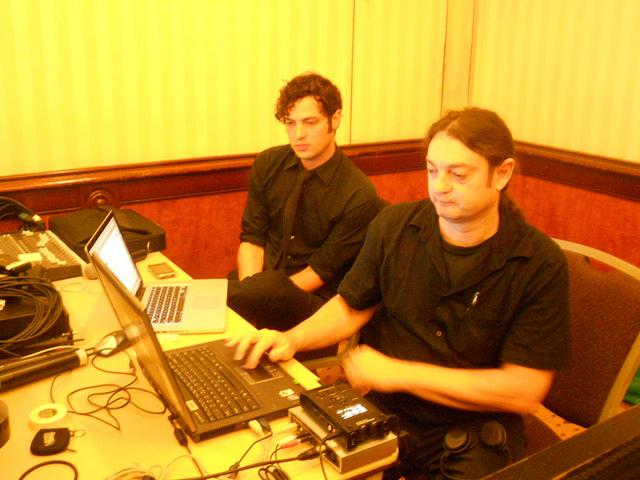Why is he looking at the other guy's laptop? learning 